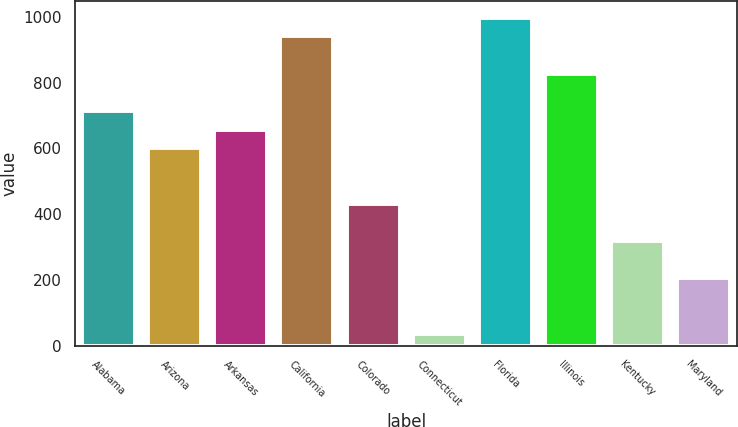Convert chart. <chart><loc_0><loc_0><loc_500><loc_500><bar_chart><fcel>Alabama<fcel>Arizona<fcel>Arkansas<fcel>California<fcel>Colorado<fcel>Connecticut<fcel>Florida<fcel>Illinois<fcel>Kentucky<fcel>Maryland<nl><fcel>714.2<fcel>601<fcel>657.6<fcel>940.6<fcel>431.2<fcel>35<fcel>997.2<fcel>827.4<fcel>318<fcel>204.8<nl></chart> 